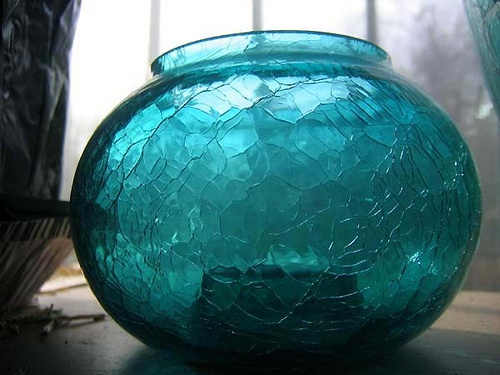Describe the objects in this image and their specific colors. I can see a vase in black, teal, and cyan tones in this image. 